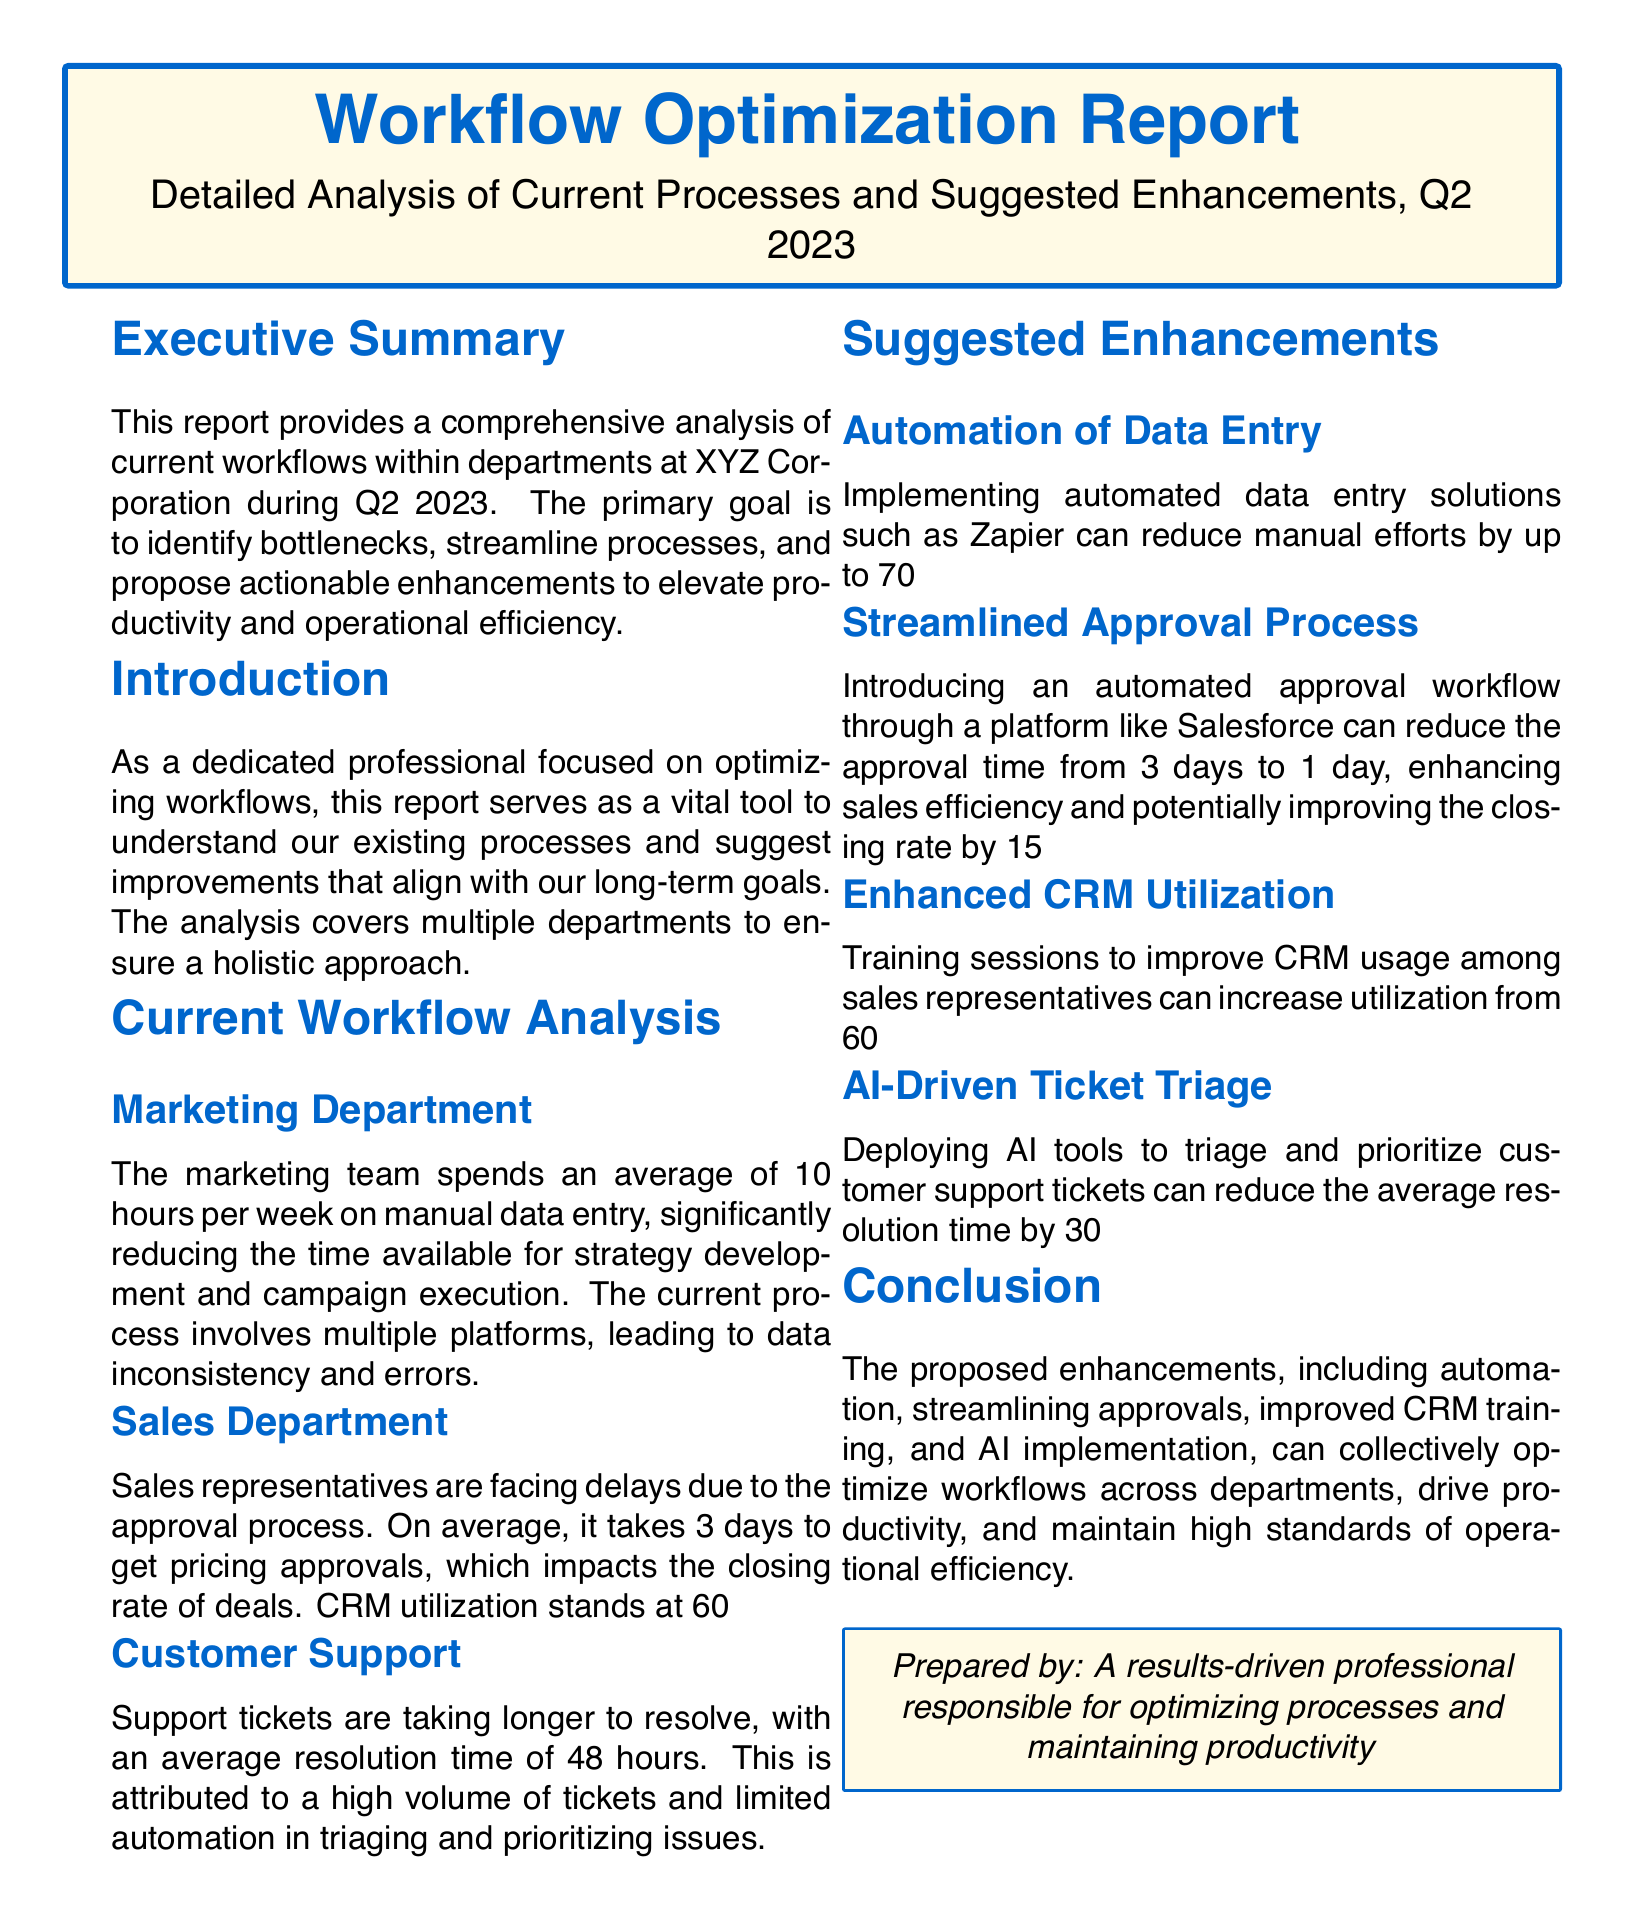What is the primary goal of the report? The primary goal is to identify bottlenecks, streamline processes, and propose actionable enhancements to elevate productivity and operational efficiency.
Answer: Identify bottlenecks How many hours per week does the marketing team spend on manual data entry? The report states that the marketing team spends an average of 10 hours per week on manual data entry.
Answer: 10 hours What is the average resolution time for customer support tickets? The average resolution time for customer support tickets is stated as 48 hours.
Answer: 48 hours By how much can the streamlined approval process enhance closing rates? The document mentions that the streamlined approval process can potentially improve the closing rate by 15%.
Answer: 15% What tool is suggested to automate data entry? The report recommends implementing automated data entry solutions such as Zapier.
Answer: Zapier What can training sessions for sales representatives improve CRM utilization to? The report indicates that training can increase CRM utilization from 60% to at least 80%.
Answer: 80% What type of tool is proposed for triaging support tickets? The document suggests deploying AI tools to triage and prioritize customer support tickets.
Answer: AI tools What is the document classification of this report? The report is identified as a Workflow Optimization Report.
Answer: Workflow Optimization Report 